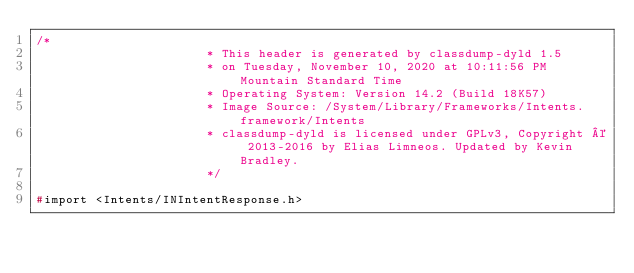Convert code to text. <code><loc_0><loc_0><loc_500><loc_500><_C_>/*
                       * This header is generated by classdump-dyld 1.5
                       * on Tuesday, November 10, 2020 at 10:11:56 PM Mountain Standard Time
                       * Operating System: Version 14.2 (Build 18K57)
                       * Image Source: /System/Library/Frameworks/Intents.framework/Intents
                       * classdump-dyld is licensed under GPLv3, Copyright © 2013-2016 by Elias Limneos. Updated by Kevin Bradley.
                       */

#import <Intents/INIntentResponse.h></code> 